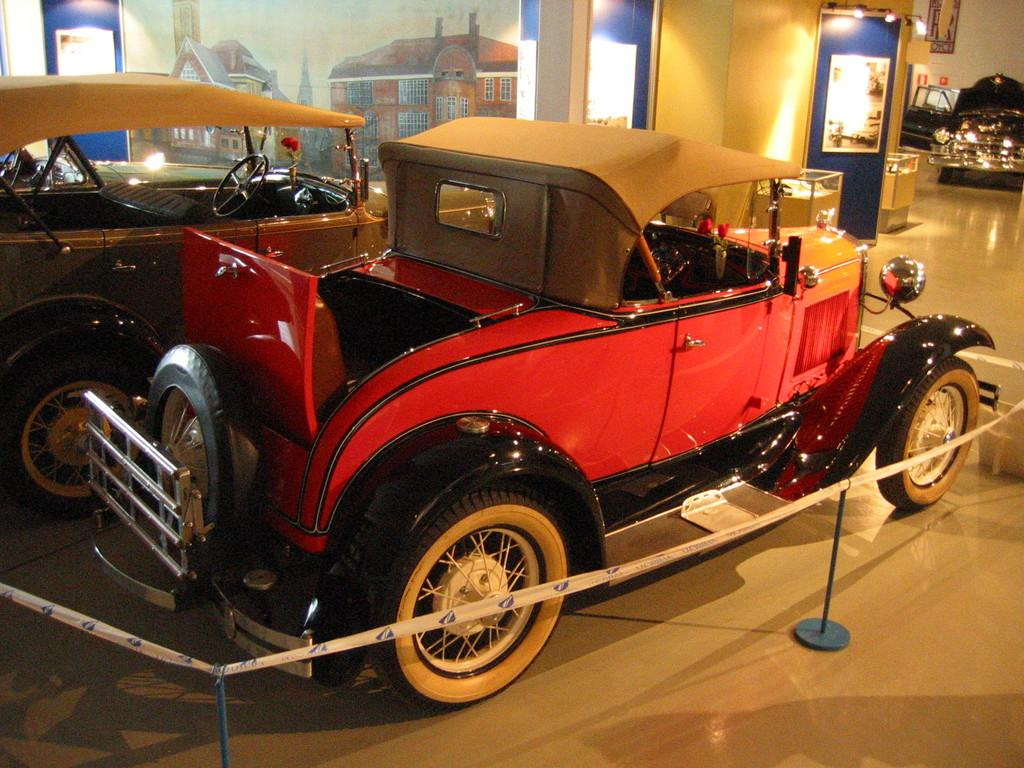What objects are on the floor in the image? There are vehicles on the floor in the image. What can be seen on the wall in the background? There is a painting of buildings on the wall in the background. What is visible in the background that provides illumination? There are lights visible in the background. What type of tape is present in the background? There is barricade tape in the background. What other objects can be seen in the background? There are other objects present in the background. What type of cloth is being sold in the store depicted in the painting on the wall? There is no store or cloth mentioned in the image; the painting on the wall depicts buildings. 